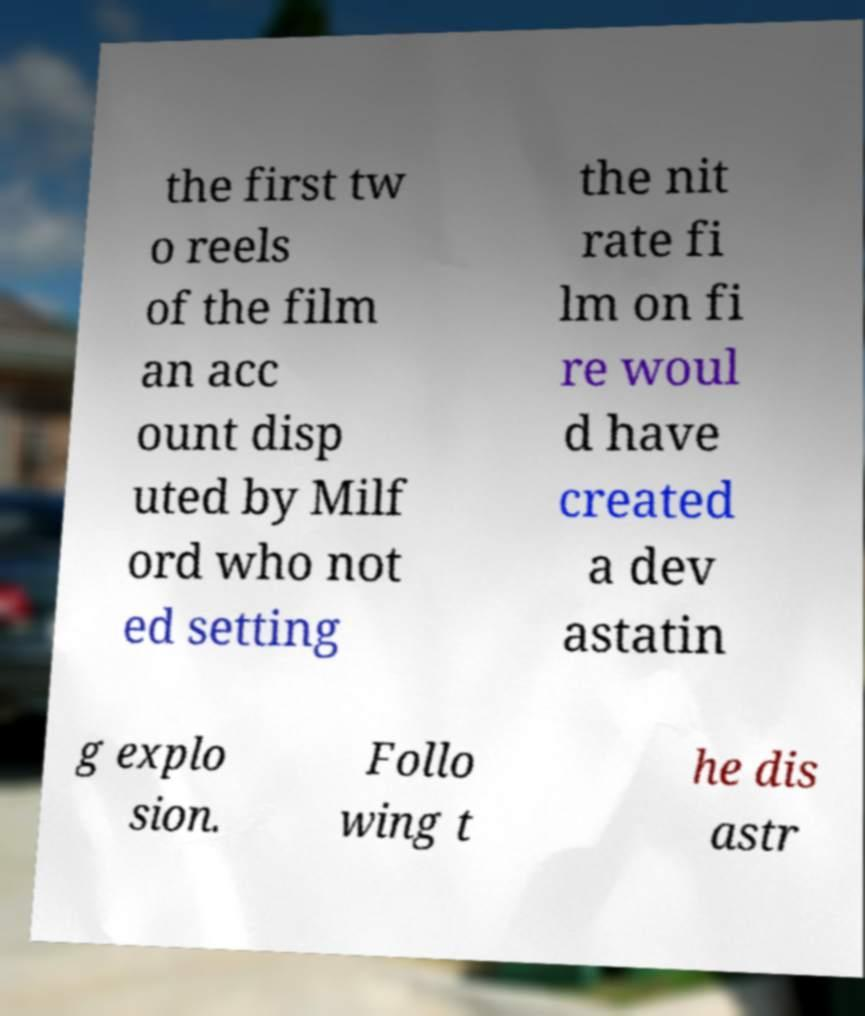What messages or text are displayed in this image? I need them in a readable, typed format. the first tw o reels of the film an acc ount disp uted by Milf ord who not ed setting the nit rate fi lm on fi re woul d have created a dev astatin g explo sion. Follo wing t he dis astr 